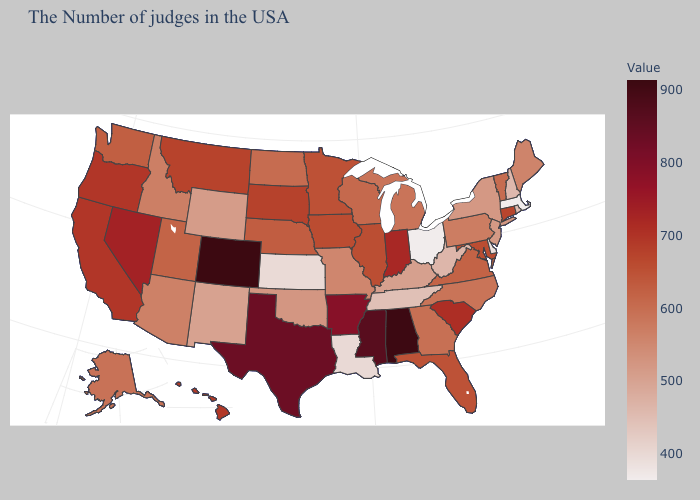Which states have the lowest value in the MidWest?
Keep it brief. Ohio. Does Colorado have the highest value in the USA?
Keep it brief. Yes. Does Ohio have the lowest value in the USA?
Keep it brief. Yes. Among the states that border Washington , does Idaho have the lowest value?
Answer briefly. Yes. Among the states that border Arkansas , does Missouri have the highest value?
Answer briefly. No. 